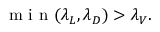<formula> <loc_0><loc_0><loc_500><loc_500>\min ( \lambda _ { L } , \lambda _ { D } ) > \lambda _ { V } .</formula> 